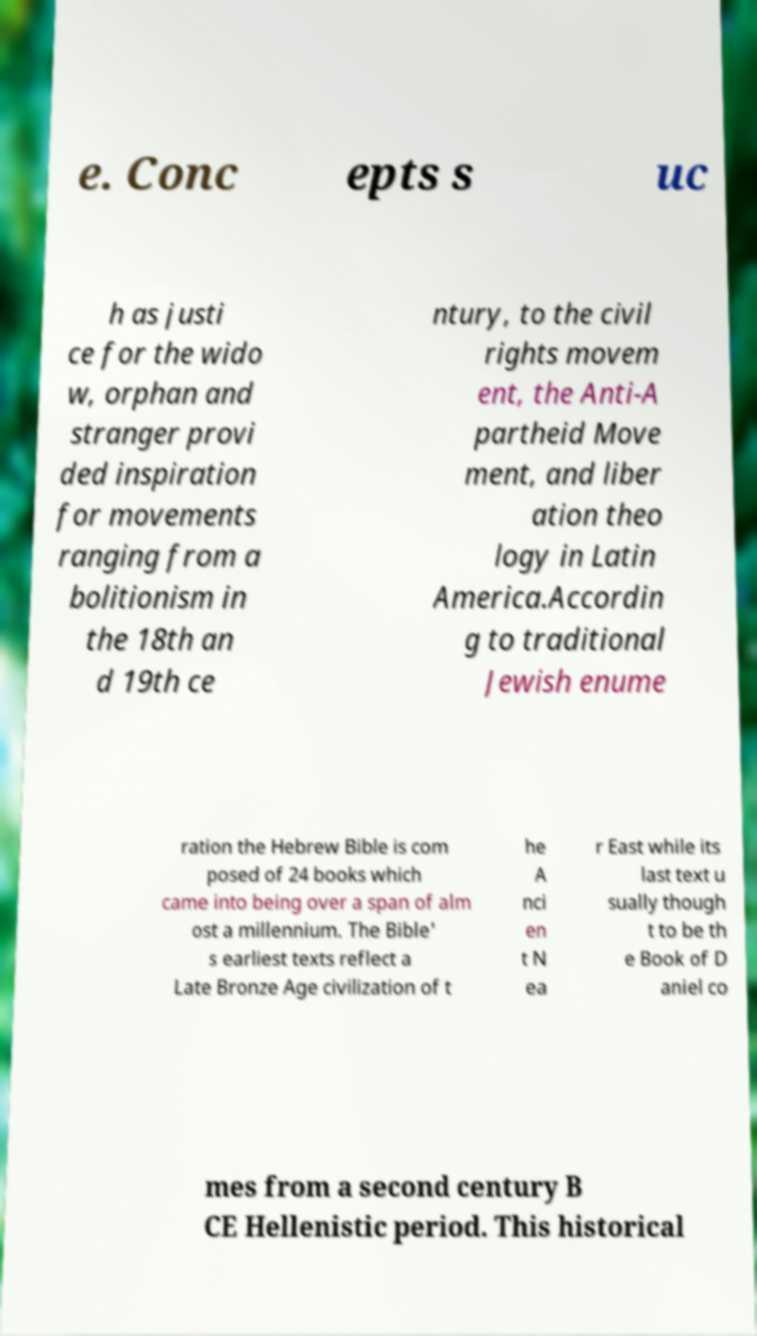Can you read and provide the text displayed in the image?This photo seems to have some interesting text. Can you extract and type it out for me? e. Conc epts s uc h as justi ce for the wido w, orphan and stranger provi ded inspiration for movements ranging from a bolitionism in the 18th an d 19th ce ntury, to the civil rights movem ent, the Anti-A partheid Move ment, and liber ation theo logy in Latin America.Accordin g to traditional Jewish enume ration the Hebrew Bible is com posed of 24 books which came into being over a span of alm ost a millennium. The Bible' s earliest texts reflect a Late Bronze Age civilization of t he A nci en t N ea r East while its last text u sually though t to be th e Book of D aniel co mes from a second century B CE Hellenistic period. This historical 